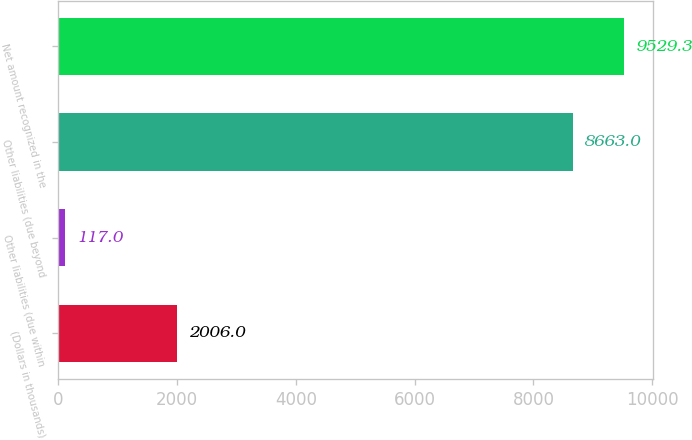Convert chart. <chart><loc_0><loc_0><loc_500><loc_500><bar_chart><fcel>(Dollars in thousands)<fcel>Other liabilities (due within<fcel>Other liabilities (due beyond<fcel>Net amount recognized in the<nl><fcel>2006<fcel>117<fcel>8663<fcel>9529.3<nl></chart> 